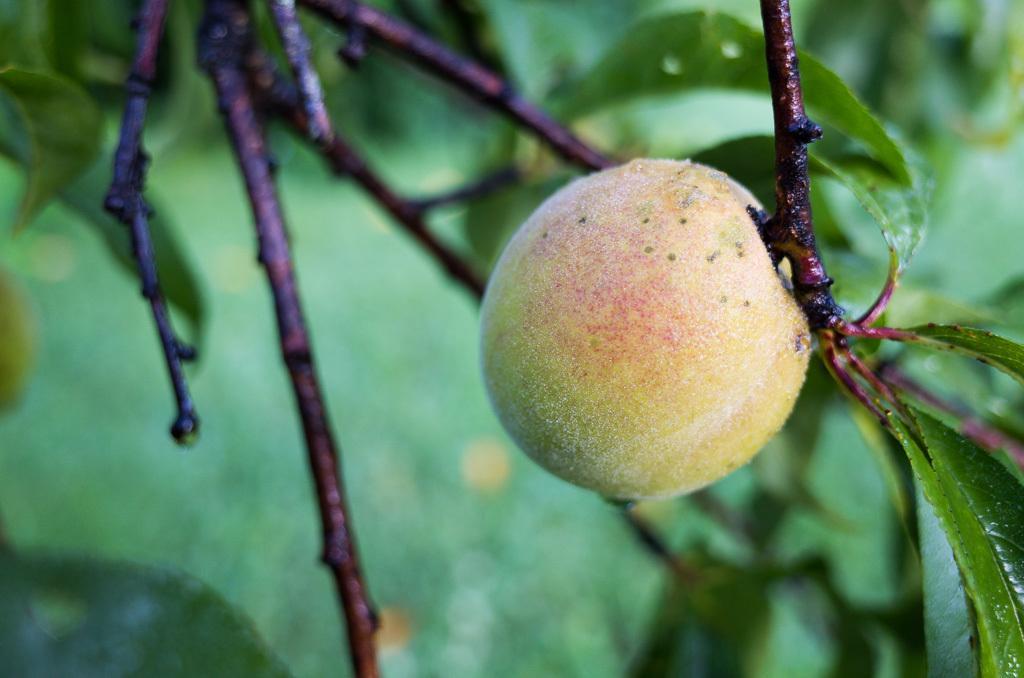How would you summarize this image in a sentence or two? In this image there is a plant to which there is a fruit. In the background there are leaves on which there are droplets of water. On the left side there are tree stems. 